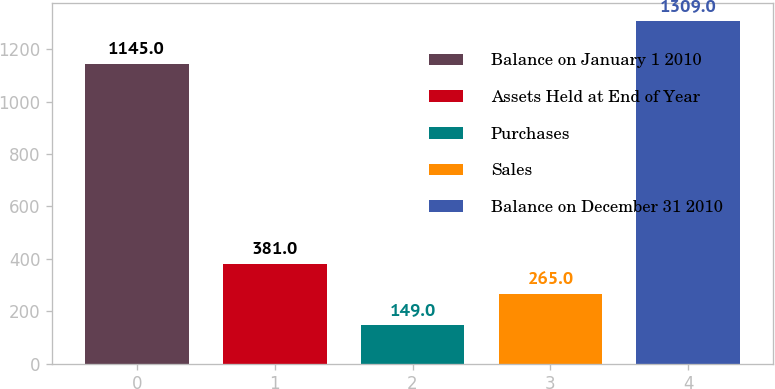<chart> <loc_0><loc_0><loc_500><loc_500><bar_chart><fcel>Balance on January 1 2010<fcel>Assets Held at End of Year<fcel>Purchases<fcel>Sales<fcel>Balance on December 31 2010<nl><fcel>1145<fcel>381<fcel>149<fcel>265<fcel>1309<nl></chart> 